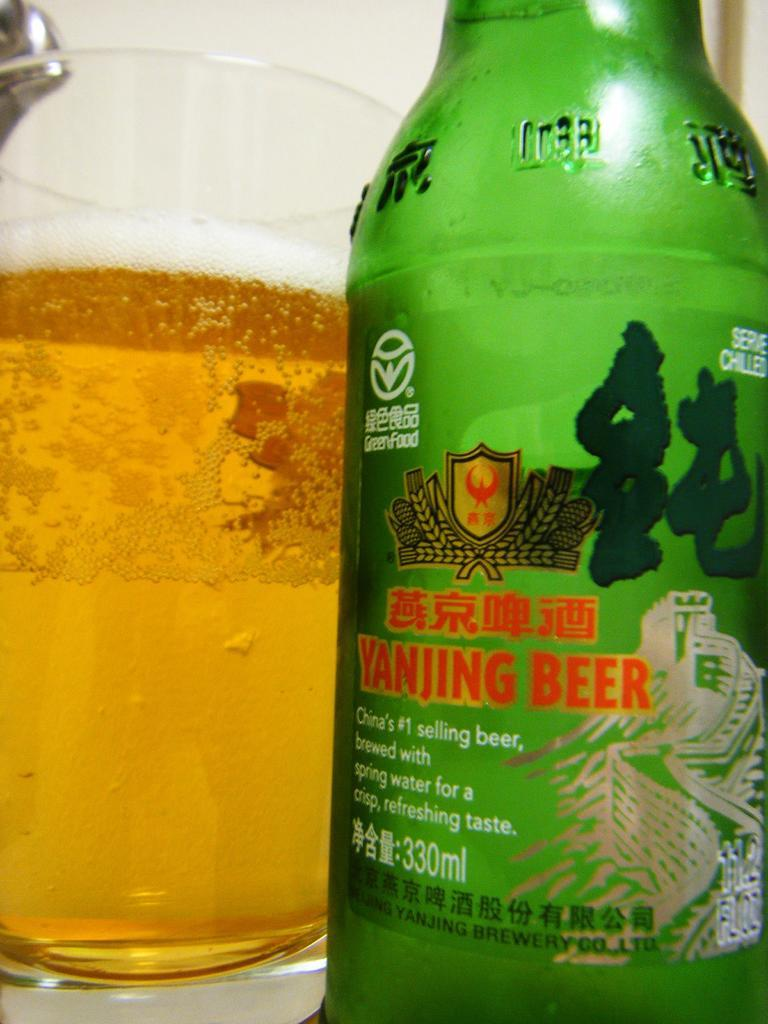<image>
Describe the image concisely. a close up of a glass and green bottle of Yanjing Beer 